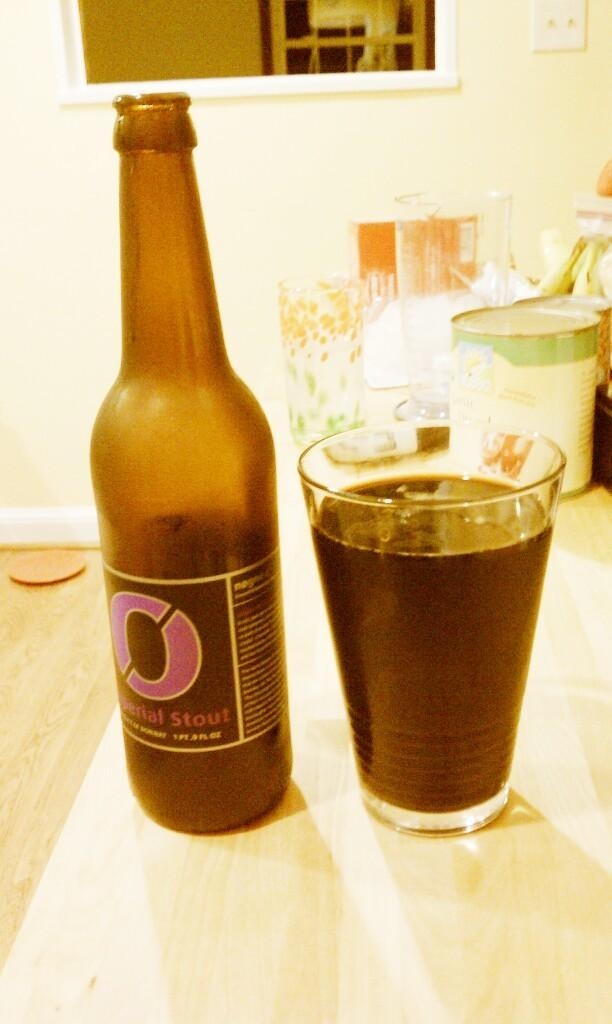<image>
Provide a brief description of the given image. A full glass of beer next to a beer bottle with a large pink O on the label. 